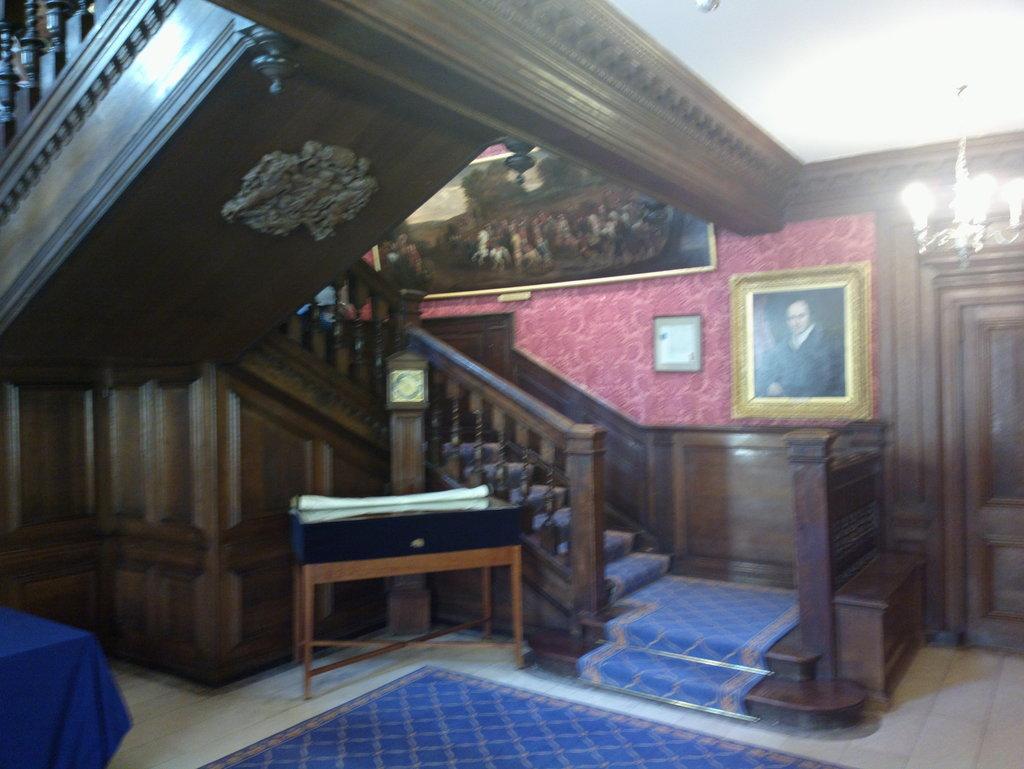Could you give a brief overview of what you see in this image? In this image i can see a floor mat, stairs, the wall, few photo frames attached to the wall, the ceiling, a chandelier and a door. 